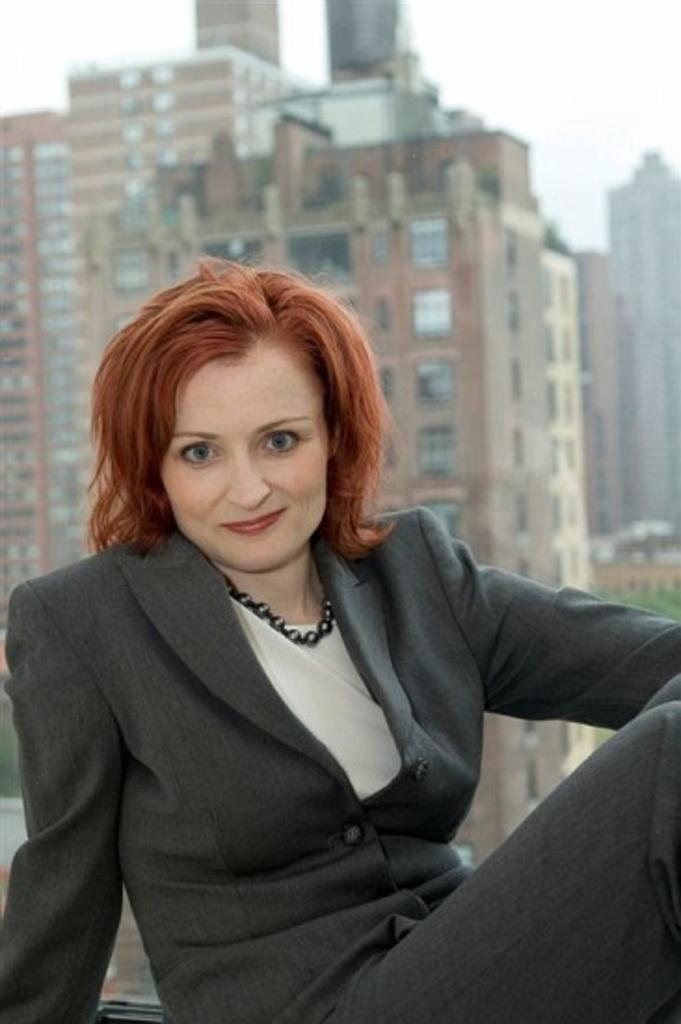Who is the main subject in the image? There is a woman in the image. What is the woman wearing? The woman is wearing a black jacket. What can be seen in the background of the image? There is a building in the background of the image. What is visible at the top of the image? The sky is visible at the top of the image. What type of goose is sitting on the woman's shoulder in the image? There is no goose present in the image; the woman is alone in the image. What type of trousers is the woman wearing in the image? The provided facts do not mention the type of trousers the woman is wearing, only the black jacket. 